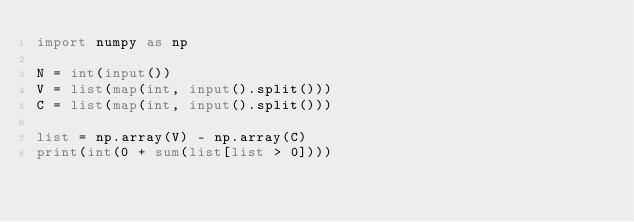<code> <loc_0><loc_0><loc_500><loc_500><_Python_>import numpy as np

N = int(input())
V = list(map(int, input().split()))
C = list(map(int, input().split()))

list = np.array(V) - np.array(C)
print(int(0 + sum(list[list > 0])))
</code> 